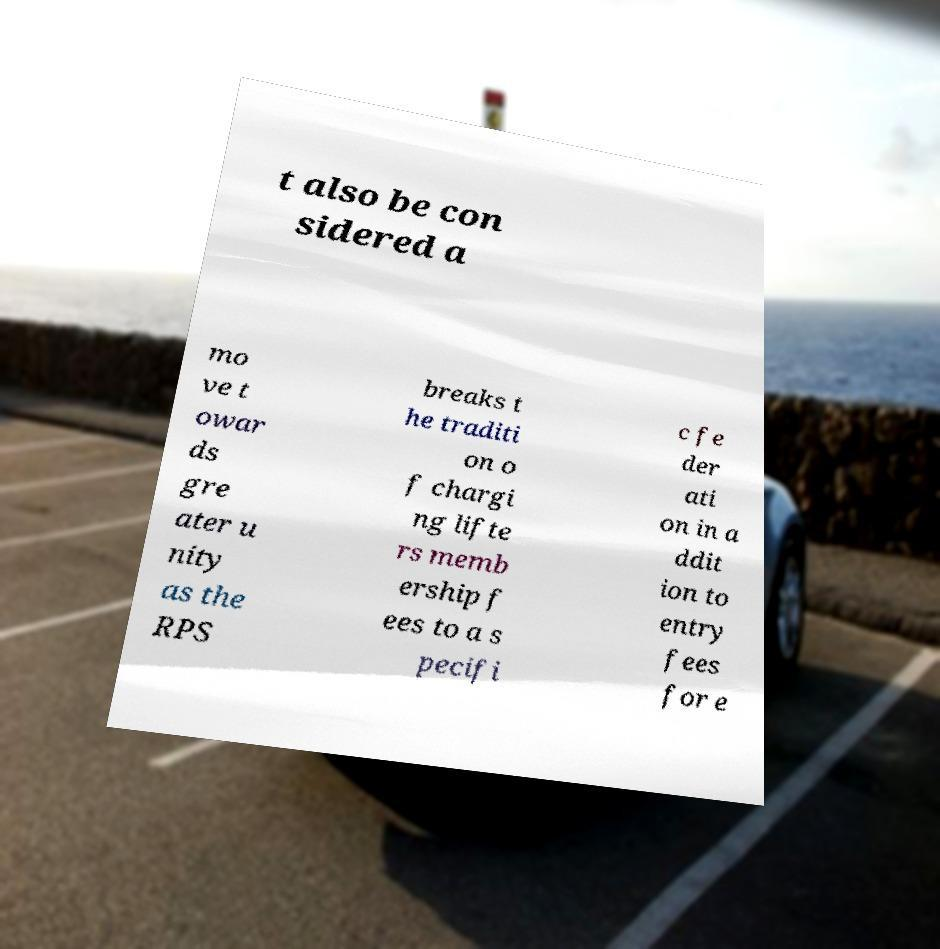Can you read and provide the text displayed in the image?This photo seems to have some interesting text. Can you extract and type it out for me? t also be con sidered a mo ve t owar ds gre ater u nity as the RPS breaks t he traditi on o f chargi ng lifte rs memb ership f ees to a s pecifi c fe der ati on in a ddit ion to entry fees for e 